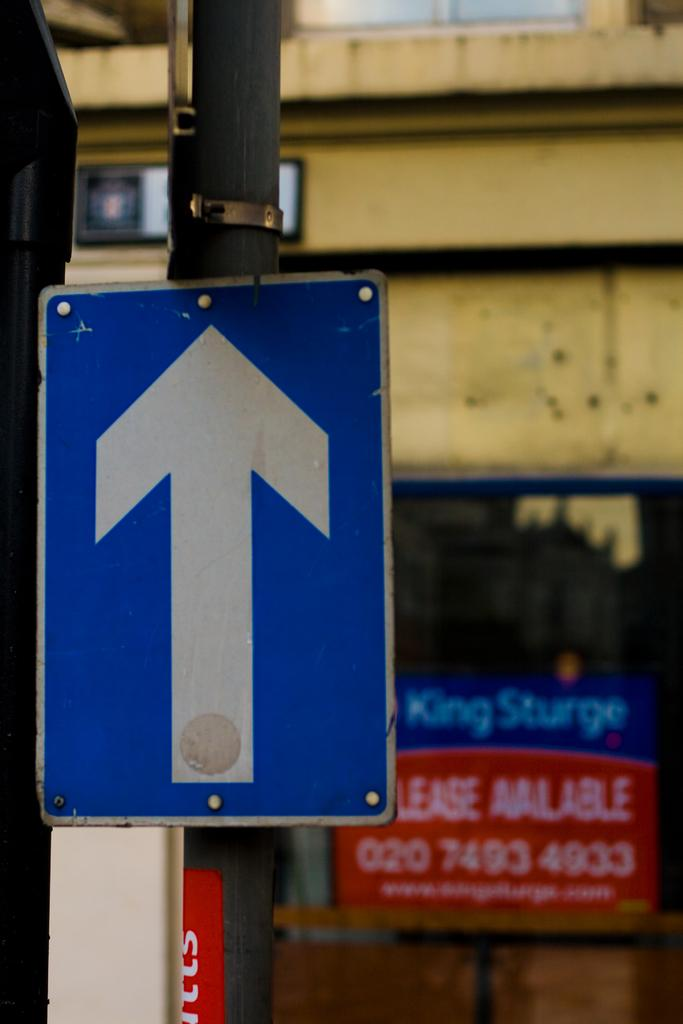<image>
Provide a brief description of the given image. A sign with an arrow pointing forward in front of a building that is available for lease. 